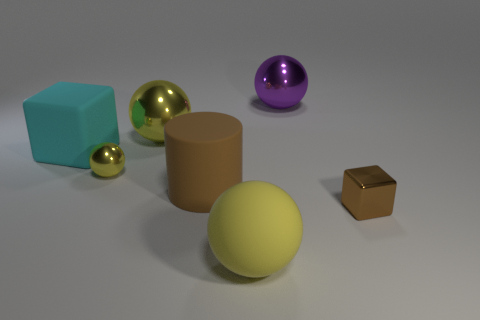Subtract all large yellow matte spheres. How many spheres are left? 3 Add 1 purple shiny spheres. How many objects exist? 8 Subtract all cyan blocks. How many blocks are left? 1 Subtract all purple cubes. How many yellow spheres are left? 3 Subtract all cylinders. How many objects are left? 6 Subtract 1 cylinders. How many cylinders are left? 0 Subtract all big gray rubber blocks. Subtract all large brown rubber cylinders. How many objects are left? 6 Add 5 small brown objects. How many small brown objects are left? 6 Add 6 purple shiny balls. How many purple shiny balls exist? 7 Subtract 0 blue spheres. How many objects are left? 7 